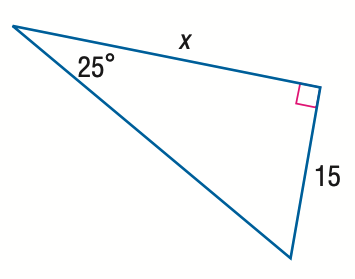Answer the mathemtical geometry problem and directly provide the correct option letter.
Question: Find x.
Choices: A: 7.0 B: 16.6 C: 32.2 D: 35.5 C 